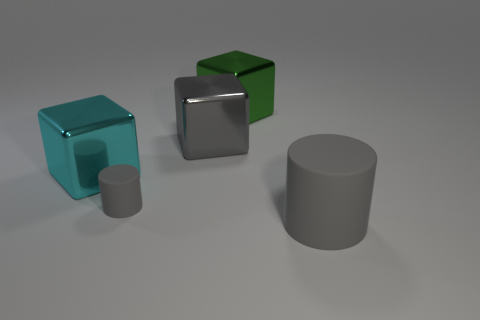Do the shiny thing that is behind the gray block and the large matte object have the same color?
Your answer should be very brief. No. Is the number of cyan matte cubes less than the number of big green metal blocks?
Ensure brevity in your answer.  Yes. What number of other things are there of the same color as the small rubber thing?
Give a very brief answer. 2. Does the big gray object that is on the left side of the big rubber cylinder have the same material as the large cyan object?
Ensure brevity in your answer.  Yes. What is the large gray object behind the tiny gray cylinder made of?
Make the answer very short. Metal. There is a gray cylinder behind the large object in front of the cyan thing; what size is it?
Your response must be concise. Small. Are there any big brown balls made of the same material as the large cyan block?
Give a very brief answer. No. What shape is the green metal object behind the big thing that is on the right side of the large green thing right of the small thing?
Give a very brief answer. Cube. Does the cylinder right of the big green metal thing have the same color as the rubber object that is to the left of the large green metallic object?
Give a very brief answer. Yes. There is a cyan metallic block; are there any large cyan shiny things to the left of it?
Keep it short and to the point. No. 